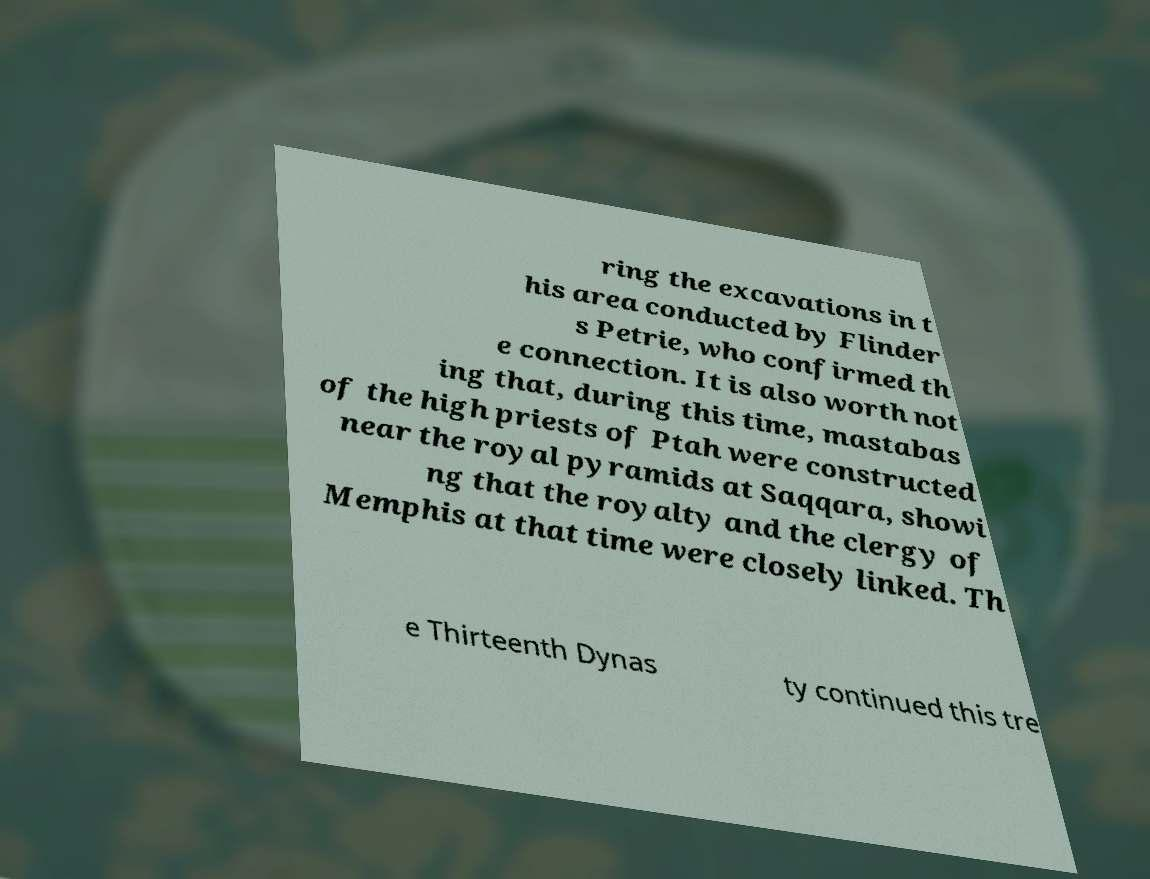Can you accurately transcribe the text from the provided image for me? ring the excavations in t his area conducted by Flinder s Petrie, who confirmed th e connection. It is also worth not ing that, during this time, mastabas of the high priests of Ptah were constructed near the royal pyramids at Saqqara, showi ng that the royalty and the clergy of Memphis at that time were closely linked. Th e Thirteenth Dynas ty continued this tre 